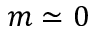<formula> <loc_0><loc_0><loc_500><loc_500>m \simeq 0</formula> 